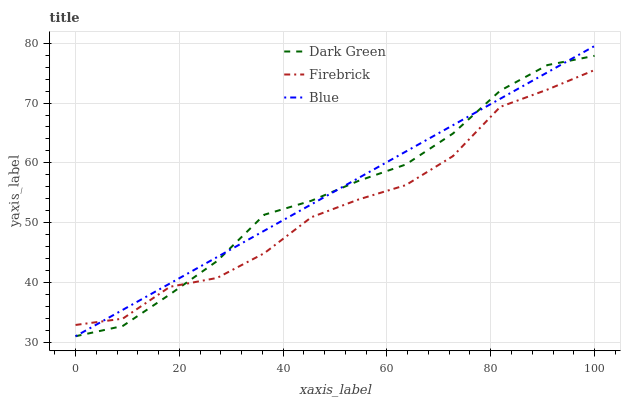Does Firebrick have the minimum area under the curve?
Answer yes or no. Yes. Does Blue have the maximum area under the curve?
Answer yes or no. Yes. Does Dark Green have the minimum area under the curve?
Answer yes or no. No. Does Dark Green have the maximum area under the curve?
Answer yes or no. No. Is Blue the smoothest?
Answer yes or no. Yes. Is Firebrick the roughest?
Answer yes or no. Yes. Is Dark Green the smoothest?
Answer yes or no. No. Is Dark Green the roughest?
Answer yes or no. No. Does Firebrick have the lowest value?
Answer yes or no. No. Does Dark Green have the highest value?
Answer yes or no. No. 